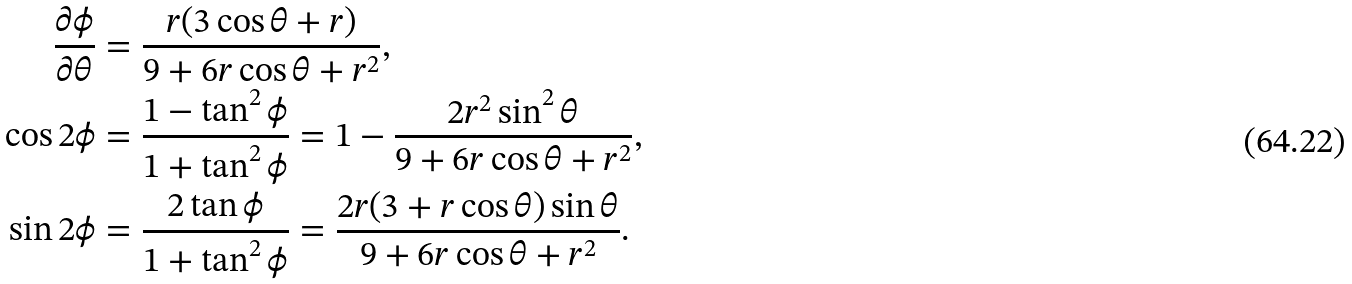<formula> <loc_0><loc_0><loc_500><loc_500>\frac { \partial \phi } { \partial \theta } & = \frac { r ( 3 \cos \theta + r ) } { 9 + 6 r \cos \theta + r ^ { 2 } } , \\ \cos 2 \phi & = \frac { 1 - \tan ^ { 2 } \phi } { 1 + \tan ^ { 2 } \phi } = 1 - \frac { 2 r ^ { 2 } \sin ^ { 2 } \theta } { 9 + 6 r \cos \theta + r ^ { 2 } } , \\ \sin 2 \phi & = \frac { 2 \tan \phi } { 1 + \tan ^ { 2 } \phi } = \frac { 2 r ( 3 + r \cos \theta ) \sin \theta } { 9 + 6 r \cos \theta + r ^ { 2 } } .</formula> 